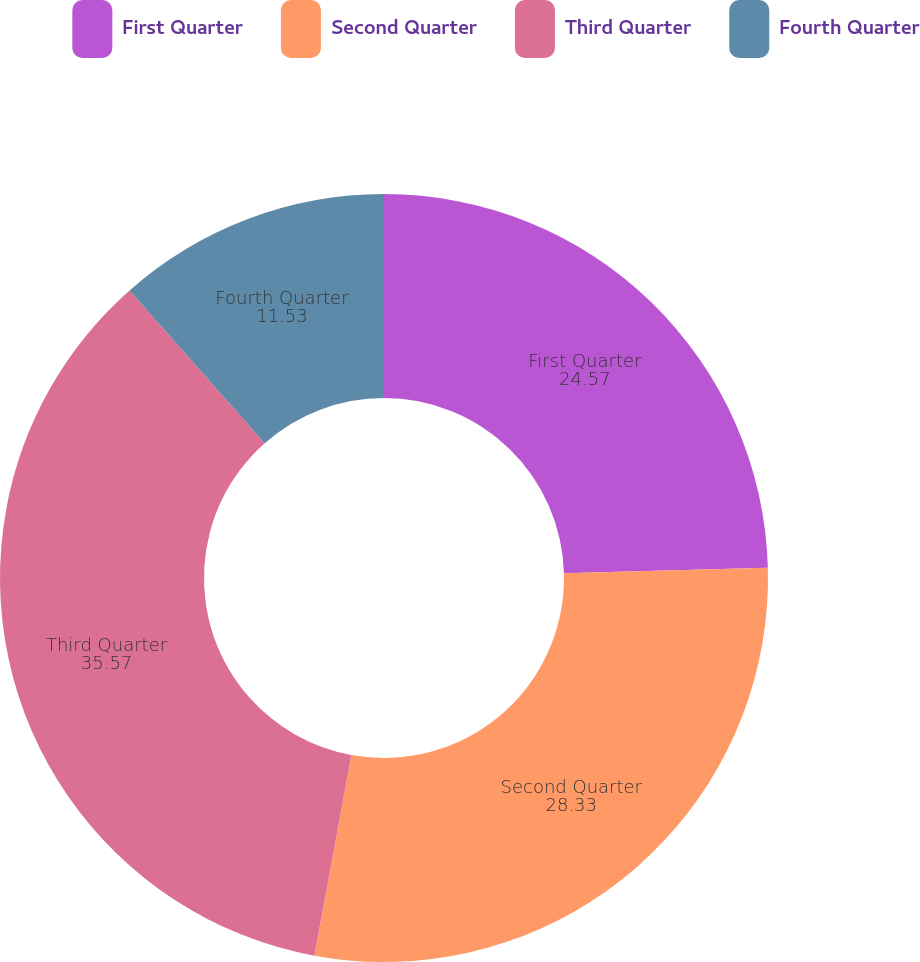Convert chart. <chart><loc_0><loc_0><loc_500><loc_500><pie_chart><fcel>First Quarter<fcel>Second Quarter<fcel>Third Quarter<fcel>Fourth Quarter<nl><fcel>24.57%<fcel>28.33%<fcel>35.57%<fcel>11.53%<nl></chart> 